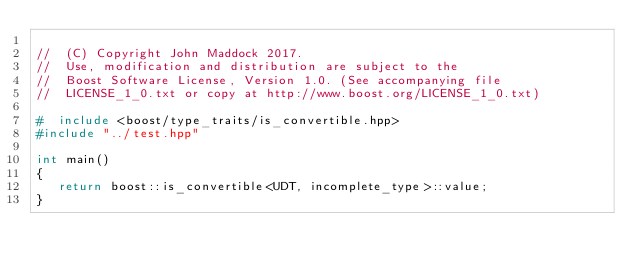<code> <loc_0><loc_0><loc_500><loc_500><_C++_>
//  (C) Copyright John Maddock 2017. 
//  Use, modification and distribution are subject to the 
//  Boost Software License, Version 1.0. (See accompanying file 
//  LICENSE_1_0.txt or copy at http://www.boost.org/LICENSE_1_0.txt)

#  include <boost/type_traits/is_convertible.hpp>
#include "../test.hpp"

int main()
{
   return boost::is_convertible<UDT, incomplete_type>::value;
}


</code> 